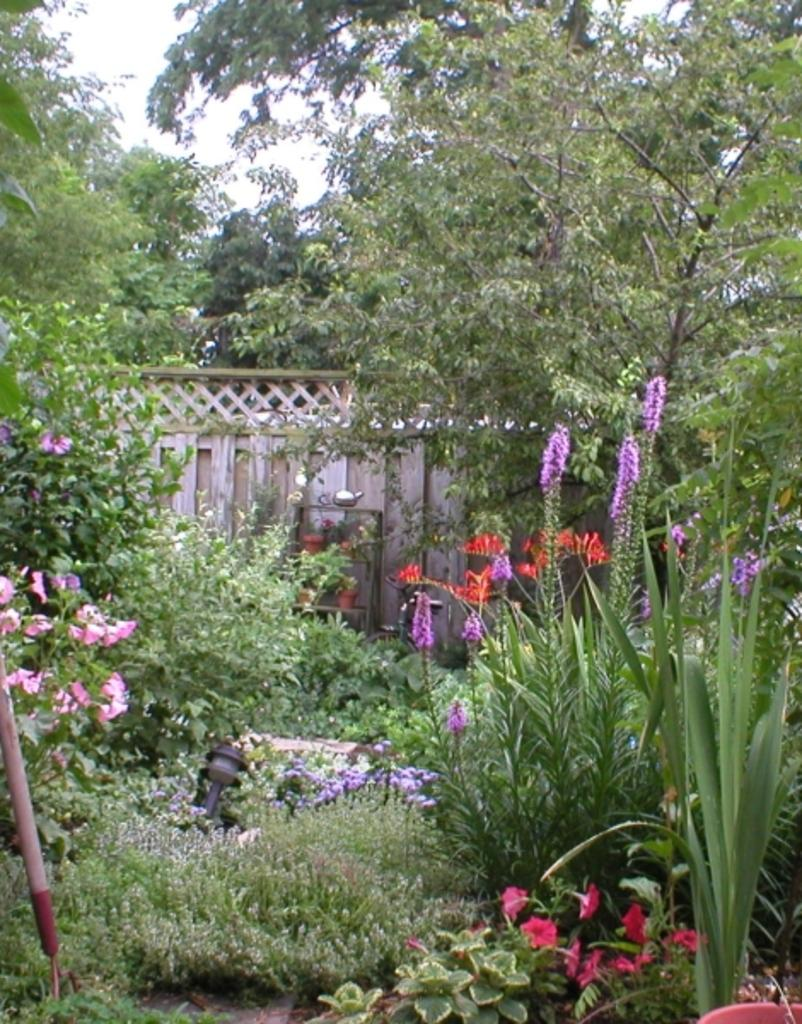What type of vegetation can be seen in the image? There is grass and plants in the image. What is visible beneath the vegetation? There is ground visible in the image. What objects are present on the ground? There are objects on the ground, but their specific nature is not mentioned in the facts. What type of containers are in the image? There are pots in the image. What structure is visible in the image? There is a wall in the image. What part of the natural environment is visible in the image? The sky is visible in the image. What type of tall vegetation is present in the image? There are trees in the image. What word is written on the tree in the image? There is no mention of any words or text written on the trees in the image. What discovery was made by the person who took the image? The facts provided do not mention any discoveries made by the person who took the image. 